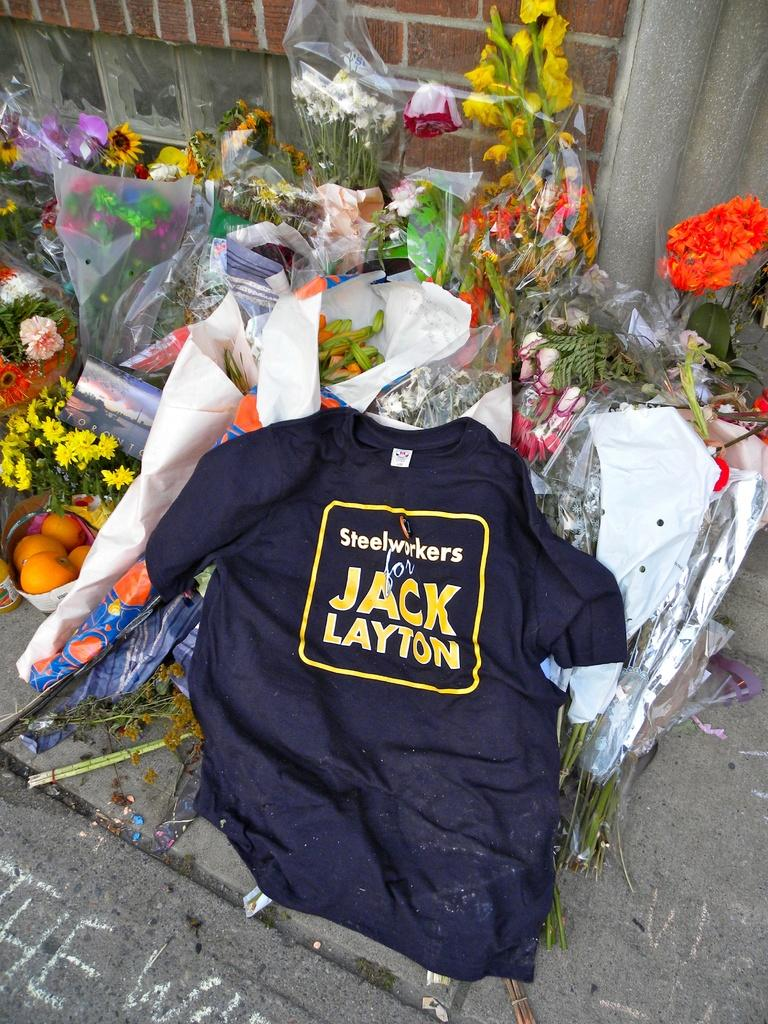What type of clothing item is in the image? There is a T-shirt in the image. What color is the T-shirt? The T-shirt is black in color. What is written or printed on the T-shirt? There is text on the T-shirt. What type of plants can be seen in the image? There are many flower bookies in the image. What kind of path is visible in the image? The image shows a footpath. What type of structure is in the background of the image? There is a brick wall in the image. What type of food is visible in the image? Fruits are present in the image. What type of cast can be seen on the T-shirt in the image? There is no cast present on the T-shirt in the image. What type of zephyr is blowing through the flower bookies in the image? There is no zephyr present in the image; it is a still image. What type of carriage is parked near the brick wall in the image? There is no carriage present in the image. 